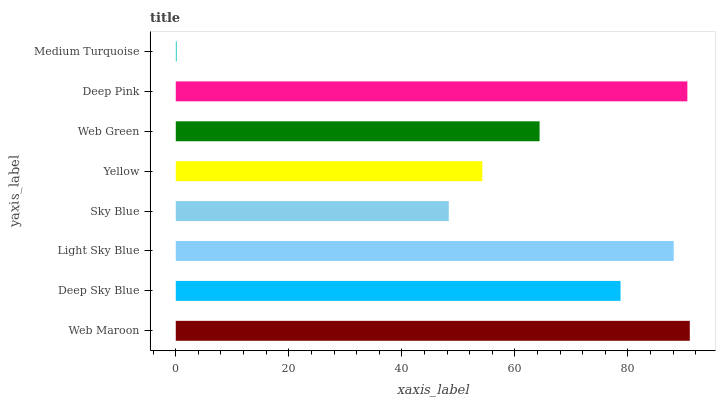Is Medium Turquoise the minimum?
Answer yes or no. Yes. Is Web Maroon the maximum?
Answer yes or no. Yes. Is Deep Sky Blue the minimum?
Answer yes or no. No. Is Deep Sky Blue the maximum?
Answer yes or no. No. Is Web Maroon greater than Deep Sky Blue?
Answer yes or no. Yes. Is Deep Sky Blue less than Web Maroon?
Answer yes or no. Yes. Is Deep Sky Blue greater than Web Maroon?
Answer yes or no. No. Is Web Maroon less than Deep Sky Blue?
Answer yes or no. No. Is Deep Sky Blue the high median?
Answer yes or no. Yes. Is Web Green the low median?
Answer yes or no. Yes. Is Yellow the high median?
Answer yes or no. No. Is Yellow the low median?
Answer yes or no. No. 